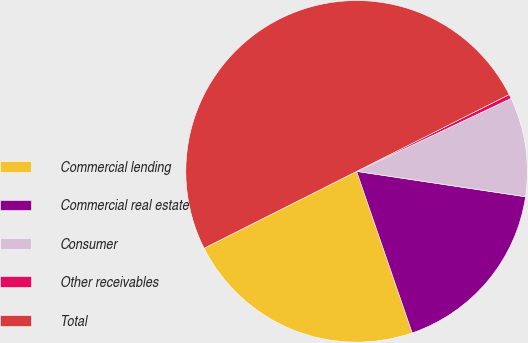<chart> <loc_0><loc_0><loc_500><loc_500><pie_chart><fcel>Commercial lending<fcel>Commercial real estate<fcel>Consumer<fcel>Other receivables<fcel>Total<nl><fcel>22.85%<fcel>17.35%<fcel>9.4%<fcel>0.4%<fcel>50.0%<nl></chart> 